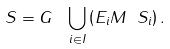Convert formula to latex. <formula><loc_0><loc_0><loc_500><loc_500>S = G \, \ \bigcup _ { i \in I } \left ( E _ { i } M \ S _ { i } \right ) .</formula> 